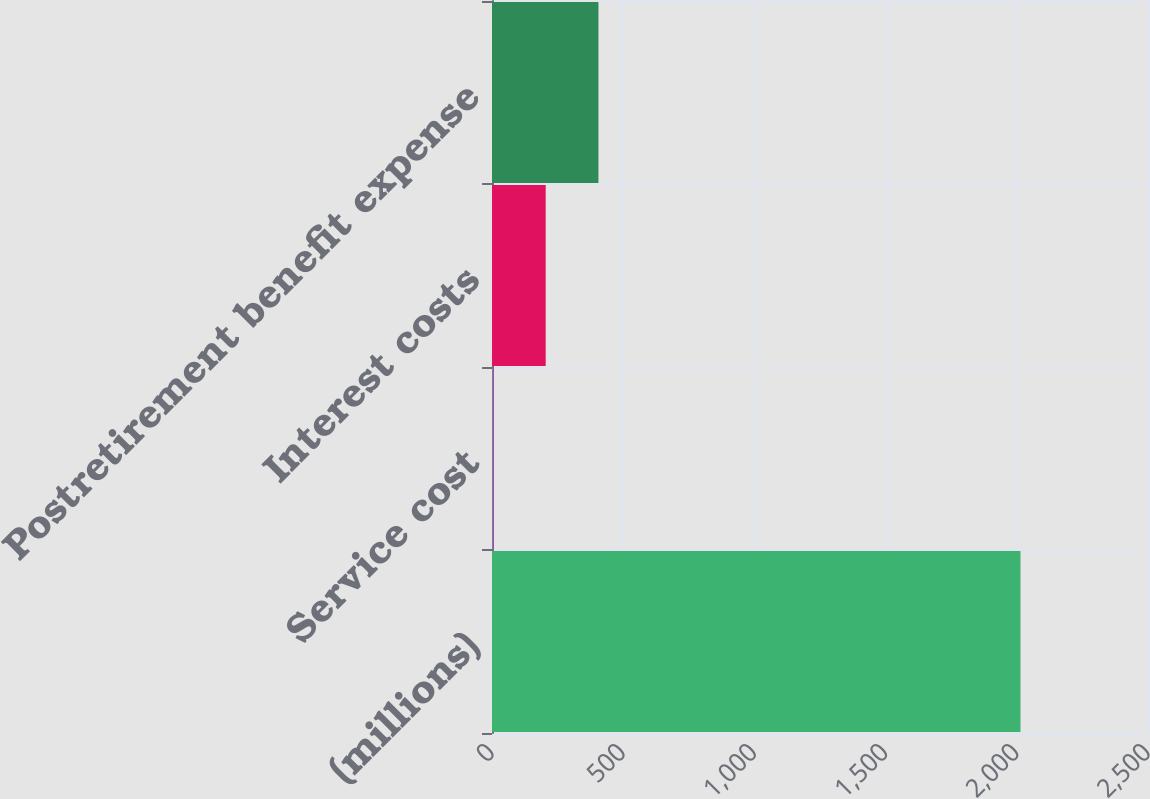Convert chart. <chart><loc_0><loc_0><loc_500><loc_500><bar_chart><fcel>(millions)<fcel>Service cost<fcel>Interest costs<fcel>Postretirement benefit expense<nl><fcel>2014<fcel>3.6<fcel>204.64<fcel>405.68<nl></chart> 